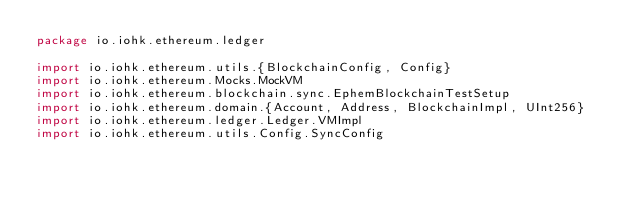Convert code to text. <code><loc_0><loc_0><loc_500><loc_500><_Scala_>package io.iohk.ethereum.ledger

import io.iohk.ethereum.utils.{BlockchainConfig, Config}
import io.iohk.ethereum.Mocks.MockVM
import io.iohk.ethereum.blockchain.sync.EphemBlockchainTestSetup
import io.iohk.ethereum.domain.{Account, Address, BlockchainImpl, UInt256}
import io.iohk.ethereum.ledger.Ledger.VMImpl
import io.iohk.ethereum.utils.Config.SyncConfig</code> 